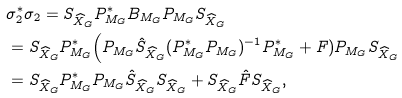<formula> <loc_0><loc_0><loc_500><loc_500>& \sigma ^ { * } _ { 2 } \sigma _ { 2 } = S _ { \widehat { X } _ { G } } P ^ { * } _ { M _ { G } } B _ { M _ { G } } P _ { M _ { G } } S _ { \widehat { X } _ { G } } \\ & = S _ { \widehat { X } _ { G } } P ^ { * } _ { M _ { G } } \Big ( P _ { M _ { G } } \hat { S } _ { \widehat { X } _ { G } } ( P ^ { * } _ { M _ { G } } P _ { M _ { G } } ) ^ { - 1 } P ^ { * } _ { M _ { G } } + F ) P _ { M _ { G } } S _ { \widehat { X } _ { G } } \\ & = S _ { \widehat { X } _ { G } } P ^ { * } _ { M _ { G } } P _ { M _ { G } } \hat { S } _ { \widehat { X } _ { G } } S _ { \widehat { X } _ { G } } + S _ { \widehat { X } _ { G } } \hat { F } S _ { \widehat { X } _ { G } } ,</formula> 